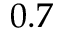<formula> <loc_0><loc_0><loc_500><loc_500>0 . 7</formula> 